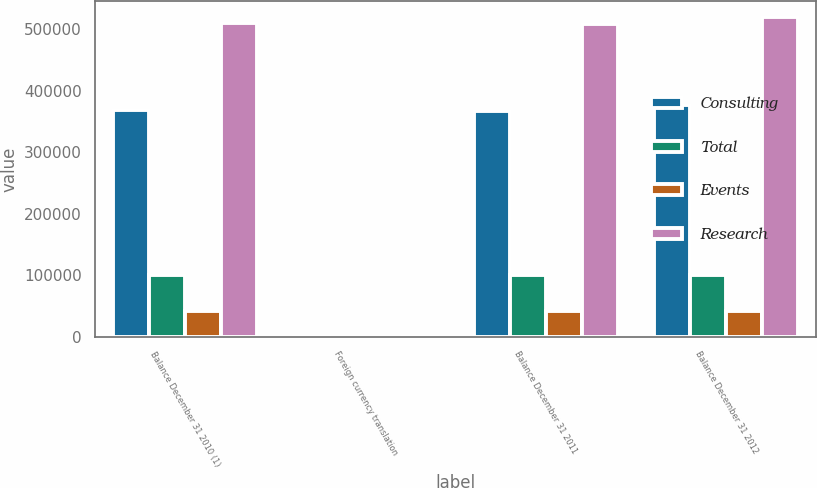Convert chart. <chart><loc_0><loc_0><loc_500><loc_500><stacked_bar_chart><ecel><fcel>Balance December 31 2010 (1)<fcel>Foreign currency translation<fcel>Balance December 31 2011<fcel>Balance December 31 2012<nl><fcel>Consulting<fcel>368521<fcel>1541<fcel>366980<fcel>377225<nl><fcel>Total<fcel>99817<fcel>140<fcel>99677<fcel>100349<nl><fcel>Events<fcel>41927<fcel>34<fcel>41893<fcel>41932<nl><fcel>Research<fcel>510265<fcel>1715<fcel>508550<fcel>519506<nl></chart> 